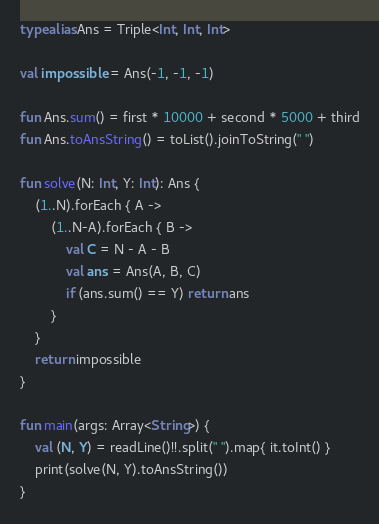Convert code to text. <code><loc_0><loc_0><loc_500><loc_500><_Kotlin_>typealias Ans = Triple<Int, Int, Int>

val impossible = Ans(-1, -1, -1)

fun Ans.sum() = first * 10000 + second * 5000 + third
fun Ans.toAnsString() = toList().joinToString(" ")

fun solve(N: Int, Y: Int): Ans {
    (1..N).forEach { A ->
        (1..N-A).forEach { B ->
            val C = N - A - B
            val ans = Ans(A, B, C)
            if (ans.sum() == Y) return ans
        }
    }
    return impossible
}

fun main(args: Array<String>) {
    val (N, Y) = readLine()!!.split(" ").map{ it.toInt() }
    print(solve(N, Y).toAnsString())
}</code> 